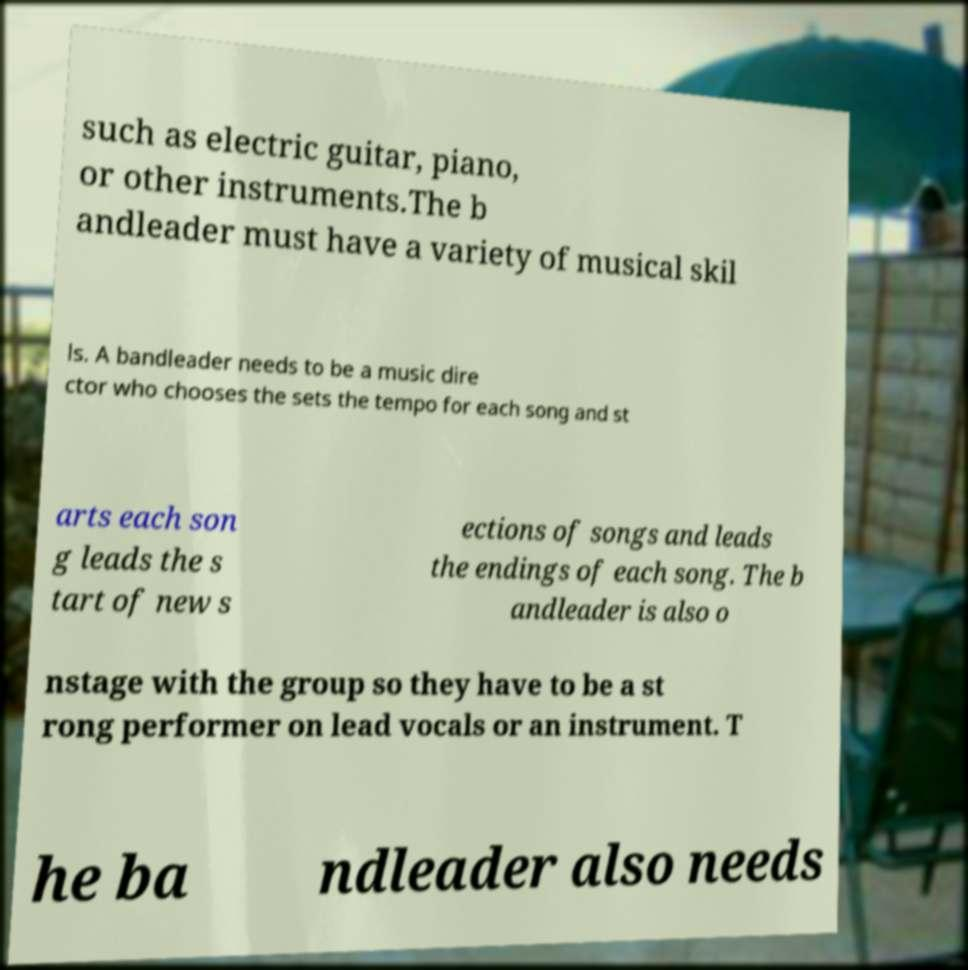Please identify and transcribe the text found in this image. such as electric guitar, piano, or other instruments.The b andleader must have a variety of musical skil ls. A bandleader needs to be a music dire ctor who chooses the sets the tempo for each song and st arts each son g leads the s tart of new s ections of songs and leads the endings of each song. The b andleader is also o nstage with the group so they have to be a st rong performer on lead vocals or an instrument. T he ba ndleader also needs 